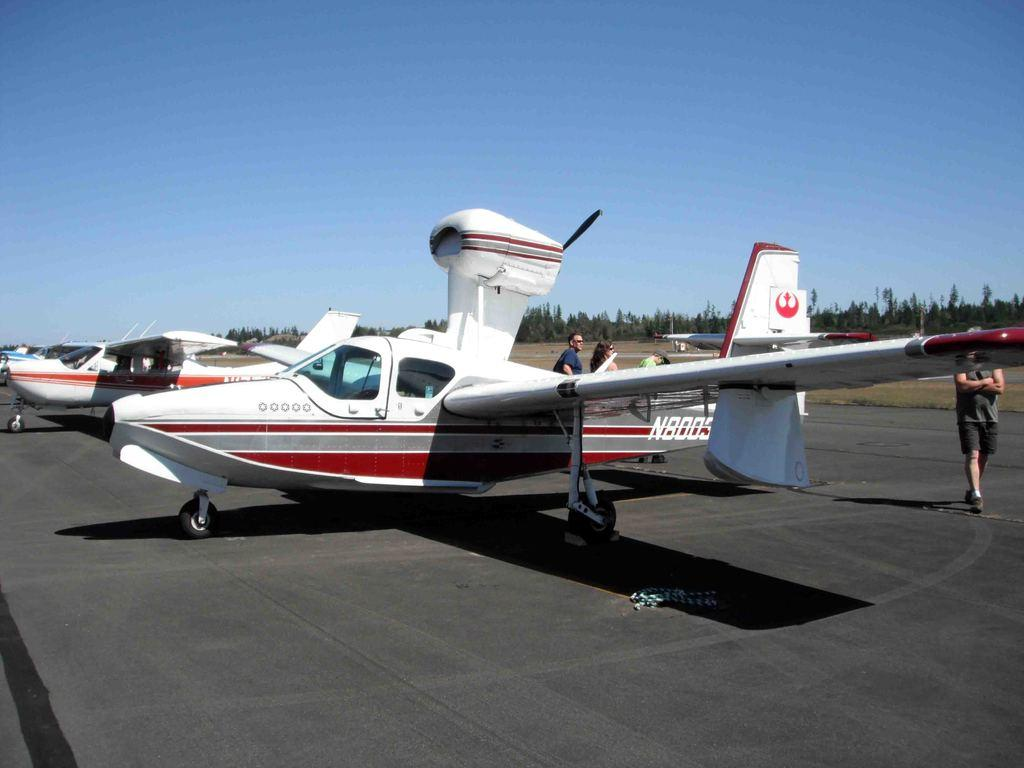What unusual objects can be seen on the road in the image? There are aeroplanes on the road in the image. What activity is taking place in the background of the image? There are people walking in the background of the image. What type of natural elements can be seen in the background of the image? Trees are present throughout the background of the image. What part of the natural environment is visible in the image? The sky is visible above the image. What language is being spoken by the aeroplanes on the road in the image? Aeroplanes do not speak languages, as they are inanimate objects. 